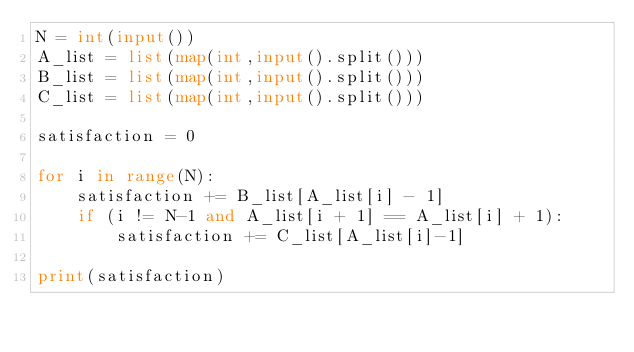<code> <loc_0><loc_0><loc_500><loc_500><_Python_>N = int(input())
A_list = list(map(int,input().split()))
B_list = list(map(int,input().split()))
C_list = list(map(int,input().split()))

satisfaction = 0

for i in range(N):
    satisfaction += B_list[A_list[i] - 1]
    if (i != N-1 and A_list[i + 1] == A_list[i] + 1):
        satisfaction += C_list[A_list[i]-1]

print(satisfaction)</code> 